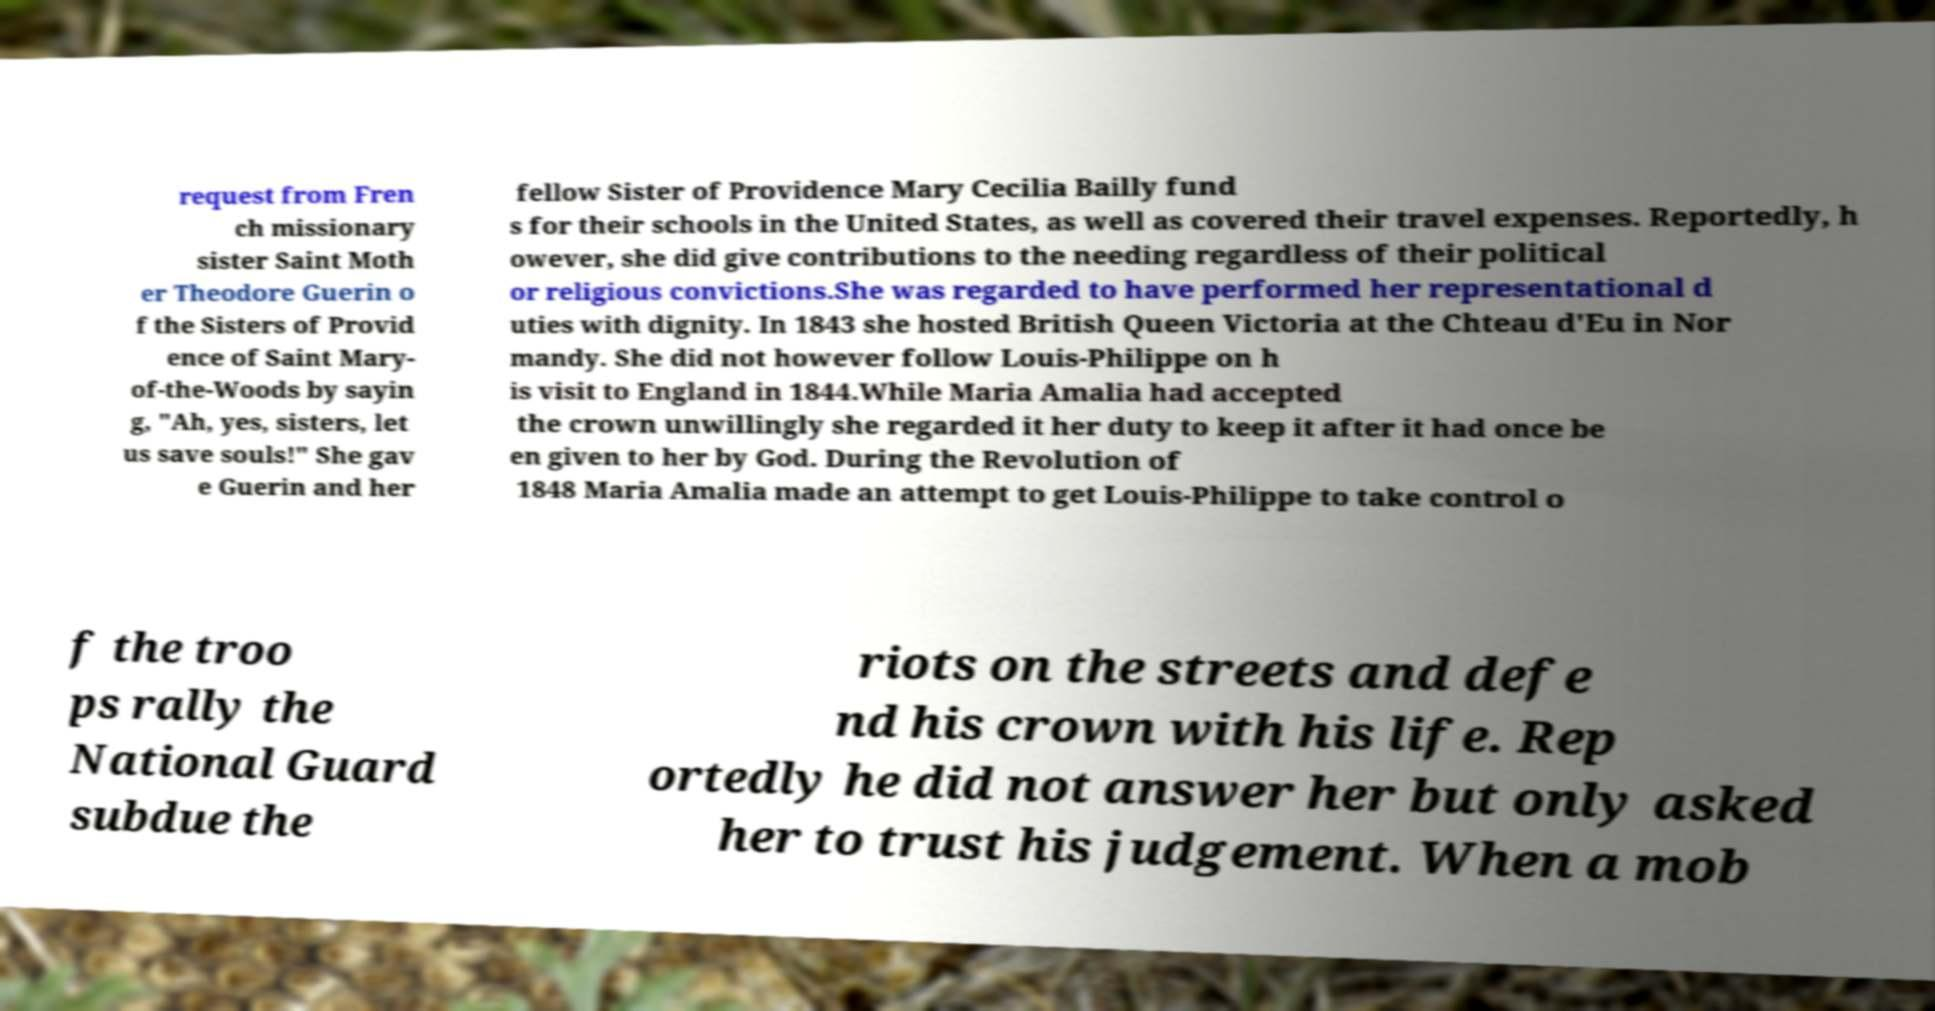There's text embedded in this image that I need extracted. Can you transcribe it verbatim? request from Fren ch missionary sister Saint Moth er Theodore Guerin o f the Sisters of Provid ence of Saint Mary- of-the-Woods by sayin g, "Ah, yes, sisters, let us save souls!" She gav e Guerin and her fellow Sister of Providence Mary Cecilia Bailly fund s for their schools in the United States, as well as covered their travel expenses. Reportedly, h owever, she did give contributions to the needing regardless of their political or religious convictions.She was regarded to have performed her representational d uties with dignity. In 1843 she hosted British Queen Victoria at the Chteau d'Eu in Nor mandy. She did not however follow Louis-Philippe on h is visit to England in 1844.While Maria Amalia had accepted the crown unwillingly she regarded it her duty to keep it after it had once be en given to her by God. During the Revolution of 1848 Maria Amalia made an attempt to get Louis-Philippe to take control o f the troo ps rally the National Guard subdue the riots on the streets and defe nd his crown with his life. Rep ortedly he did not answer her but only asked her to trust his judgement. When a mob 